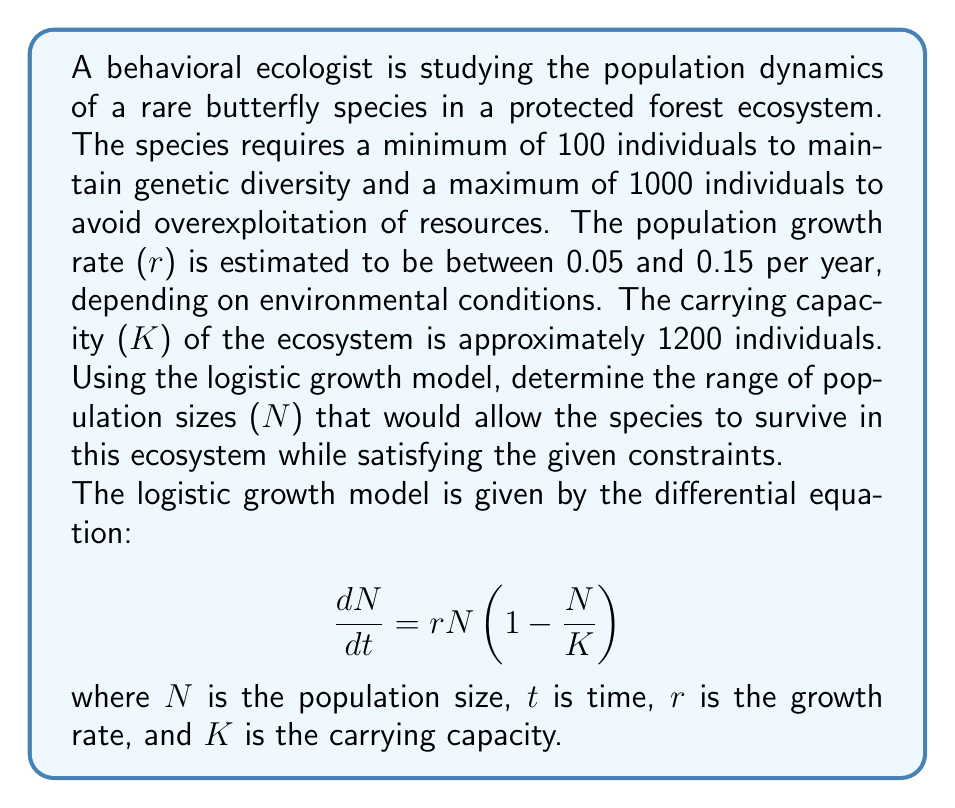Give your solution to this math problem. To solve this problem, we need to consider the constraints and use the logistic growth model to determine the range of sustainable population sizes.

1. First, let's identify the constraints:
   - Minimum population size: 100 individuals
   - Maximum population size: 1000 individuals
   - Growth rate (r): 0.05 ≤ r ≤ 0.15
   - Carrying capacity (K): 1200 individuals

2. In the logistic growth model, the population will be in equilibrium when $\frac{dN}{dt} = 0$. This occurs when either N = 0 or N = K. However, N = 0 is not a viable solution for species survival, so we focus on the non-zero equilibrium point.

3. To find the range of sustainable population sizes, we need to determine the minimum and maximum values of N that satisfy the given constraints and allow for positive population growth.

4. The population growth rate is positive when:

   $$rN(1 - \frac{N}{K}) > 0$$

5. Solving this inequality:
   
   $$N(1 - \frac{N}{K}) > 0$$
   $$0 < N < K$$

6. Given the carrying capacity K = 1200, the upper limit of N is already constrained to 1000 by the maximum population size constraint.

7. For the lower limit, we need to ensure that the population growth rate is sufficiently positive to overcome potential environmental fluctuations and maintain genetic diversity. We can use the minimum growth rate (r = 0.05) to find the population size at which the growth rate becomes negligible:

   $$0.05N(1 - \frac{N}{1200}) = \epsilon$$

   Where ε is a small positive value representing the minimum acceptable growth rate. For this problem, let's assume ε = 1 (one individual per year).

8. Solving this equation:

   $$0.05N - \frac{0.05N^2}{1200} = 1$$
   $$0.05N^2 - 60N + 1200 = 0$$

   Using the quadratic formula, we get:
   
   $$N \approx 21.7 \text{ or } N \approx 1178.3$$

9. The lower solution (N ≈ 21.7) is below our minimum population size constraint of 100, so we use 100 as our lower limit.

Therefore, the range of sustainable population sizes is between 100 and 1000 individuals.
Answer: The range of population sizes that would allow the butterfly species to survive in this ecosystem while satisfying the given constraints is $100 \leq N \leq 1000$ individuals. 